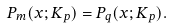Convert formula to latex. <formula><loc_0><loc_0><loc_500><loc_500>P _ { m } ( x ; K _ { p } ) = P _ { q } ( x ; K _ { p } ) .</formula> 